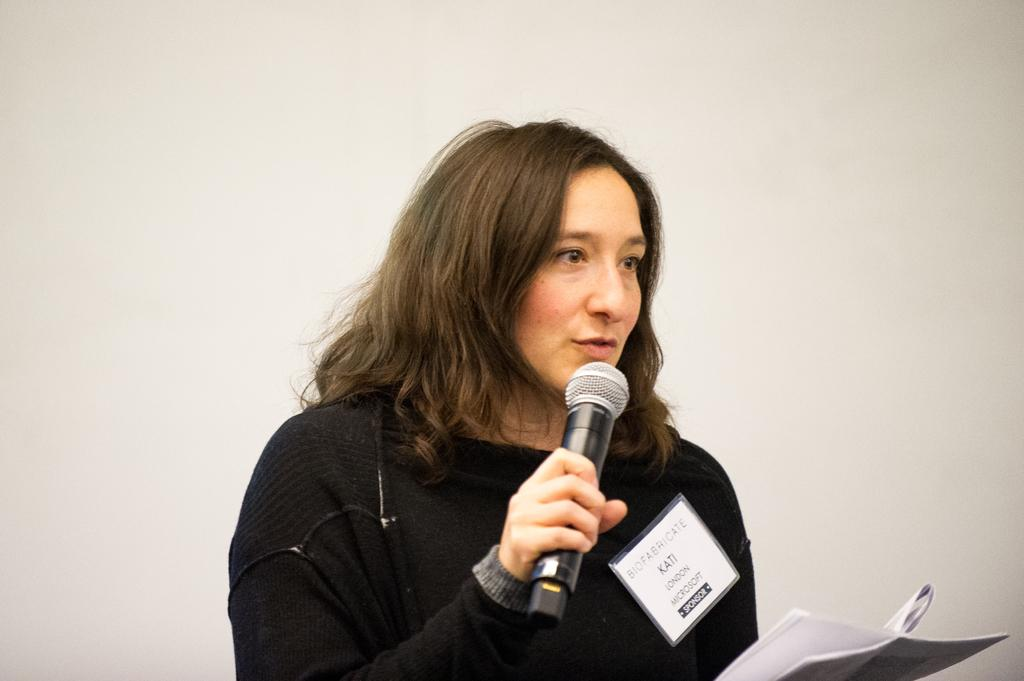Who is the main subject in the image? There is a woman in the image. What is the woman wearing? The woman is wearing a black dress. Can you describe the woman's hairstyle? The woman has short hair. What is the woman holding in her hands? The woman is holding a microphone and a paper. What might the woman be doing in the image? The woman appears to be speaking, possibly giving a presentation or speech. Can you tell me how many basketballs are visible in the image? There are no basketballs present in the image. What type of branch is the woman holding in her hand? There is no branch present in the image; the woman is holding a microphone and a paper. 